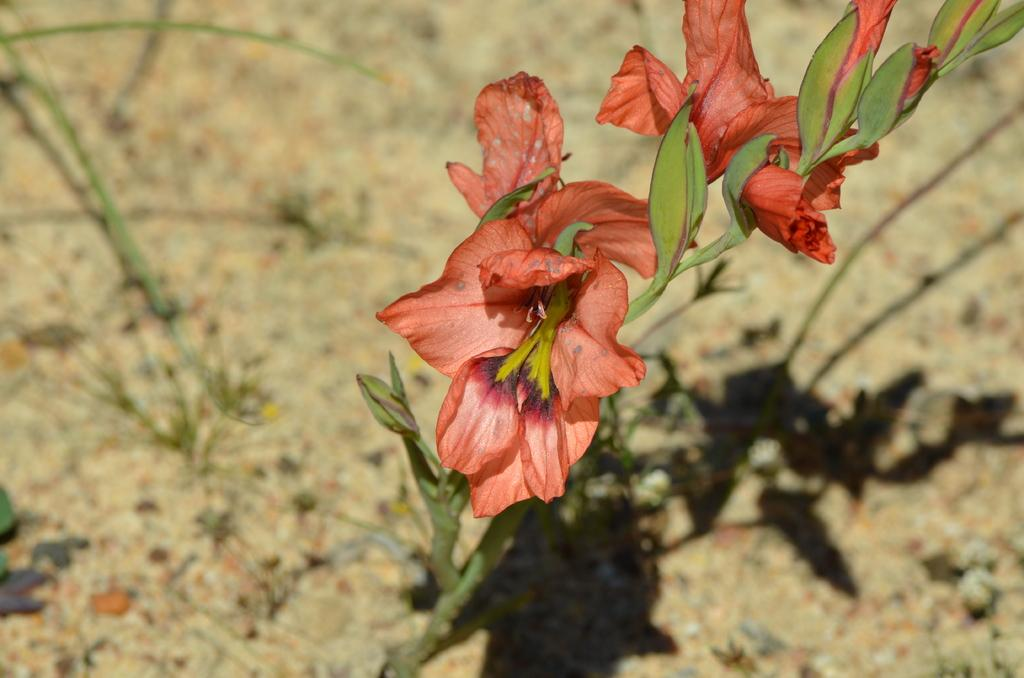What color are the flowers in the image? The flowers in the image are orange-colored. What other plant elements can be seen in the image besides the flowers? There are green-colored leaves in the image. What can be observed in the background of the image? Shadows are visible in the background of the image. How would you describe the overall clarity of the image? The image appears to be slightly blurry in the background. What type of noise can be heard coming from the paper in the image? There is no paper present in the image, so it is not possible to determine what noise might be heard. 